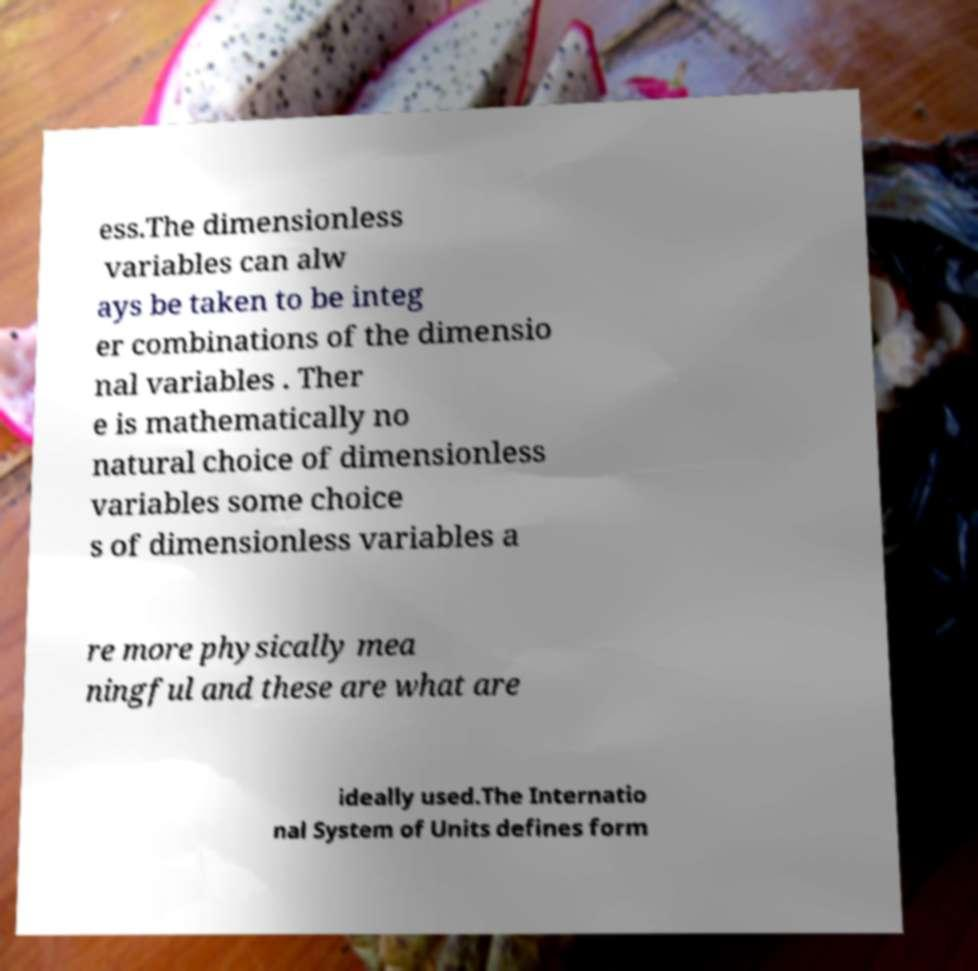Can you read and provide the text displayed in the image?This photo seems to have some interesting text. Can you extract and type it out for me? ess.The dimensionless variables can alw ays be taken to be integ er combinations of the dimensio nal variables . Ther e is mathematically no natural choice of dimensionless variables some choice s of dimensionless variables a re more physically mea ningful and these are what are ideally used.The Internatio nal System of Units defines form 